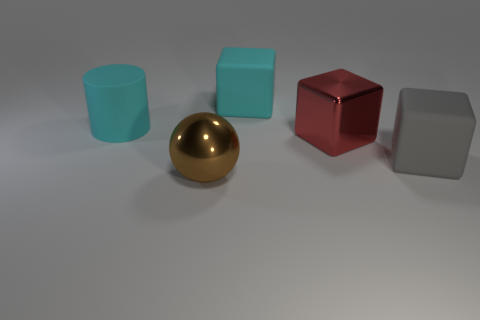Is there anything else that is the same shape as the brown thing?
Offer a terse response. No. Does the cyan thing that is behind the large cyan rubber cylinder have the same size as the thing that is in front of the gray cube?
Your answer should be compact. Yes. Are there any green blocks made of the same material as the gray thing?
Keep it short and to the point. No. What is the shape of the big brown metallic thing?
Make the answer very short. Sphere. What is the shape of the large cyan object that is left of the large rubber cube behind the big gray object?
Make the answer very short. Cylinder. What number of other things are there of the same shape as the large gray rubber thing?
Your answer should be very brief. 2. There is a gray thing that is in front of the metallic thing right of the brown metal sphere; what size is it?
Offer a terse response. Large. Are there any large brown matte blocks?
Keep it short and to the point. No. There is a cyan object that is on the right side of the large cyan rubber cylinder; how many things are in front of it?
Give a very brief answer. 4. What shape is the large cyan object that is in front of the large cyan block?
Your answer should be compact. Cylinder. 